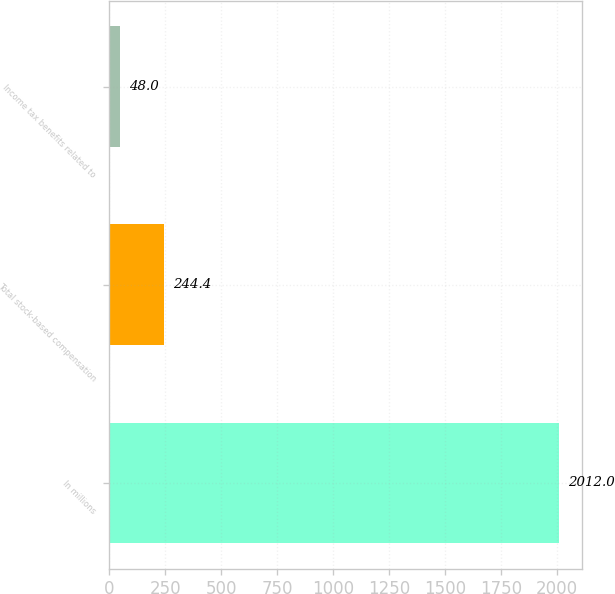<chart> <loc_0><loc_0><loc_500><loc_500><bar_chart><fcel>In millions<fcel>Total stock-based compensation<fcel>Income tax benefits related to<nl><fcel>2012<fcel>244.4<fcel>48<nl></chart> 